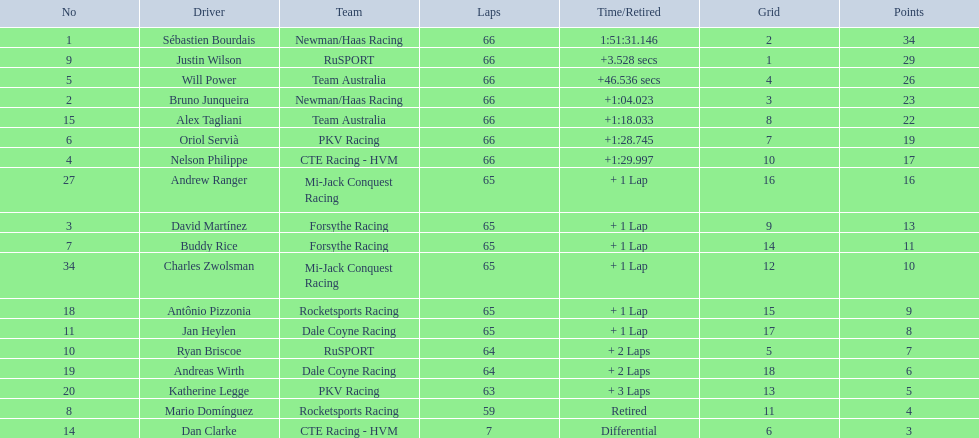Which driver has the same number as his/her position? Sébastien Bourdais. 